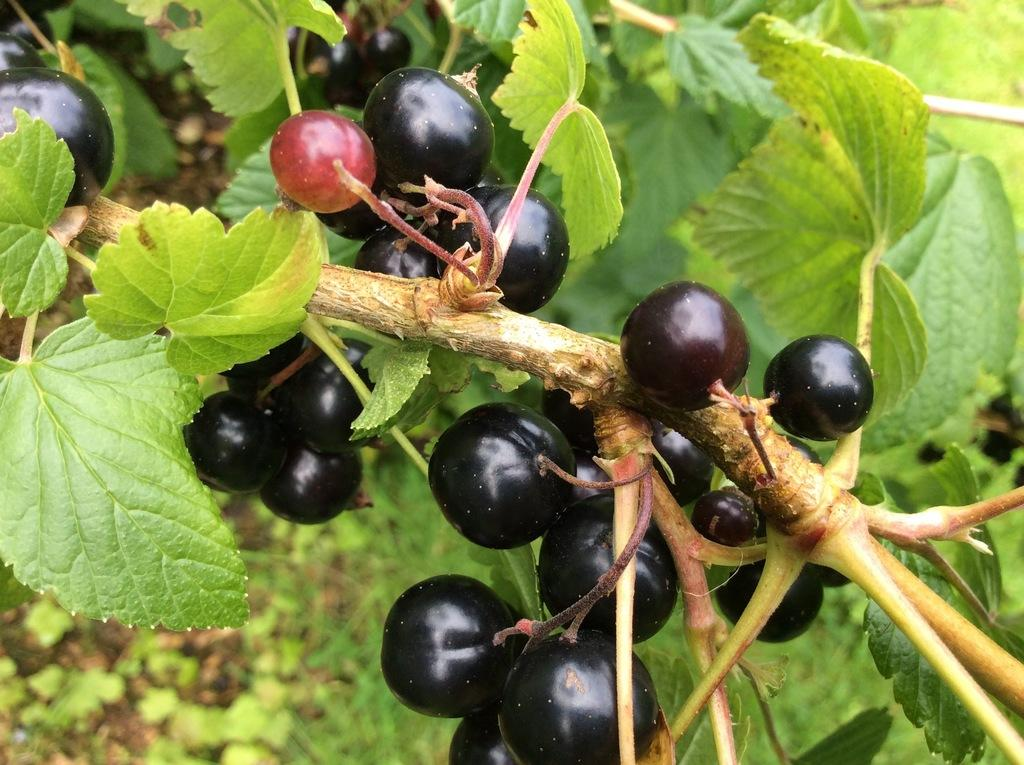What color are the seedless fruits in the image? The seedless fruits in the image are black. What type of vegetation is present in the image? There are green leaves in the image. Where is the camp located in the image? There is no camp present in the image. What direction is the sun shining from in the image? The image does not show the sun, so it cannot be determined from which direction the sun is shining. 